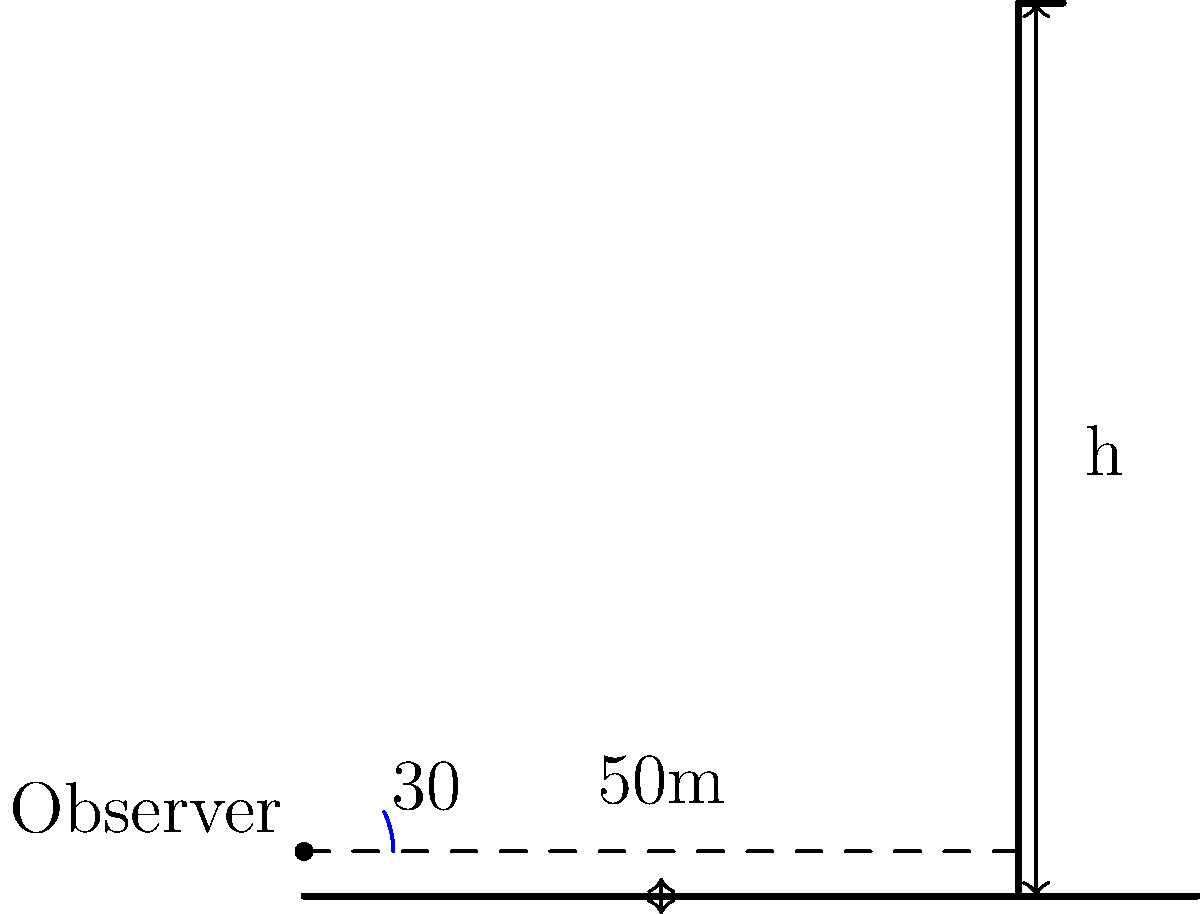As an Instagrammer looking to boost engagement, you're creating a post about a tall building in your city. You're standing 50 meters away from the base of the building and observe its top at an angle of 30° above the horizontal. Using the tangent function, calculate the height of the building. Round your answer to the nearest meter. Let's approach this step-by-step:

1) In this problem, we're dealing with a right-angled triangle. The building's height is the opposite side, and the distance from the observer to the building is the adjacent side.

2) We know that:
   - The angle of elevation is 30°
   - The adjacent side (distance to the building) is 50 meters

3) We need to find the opposite side (height of the building). Let's call this height $h$.

4) The tangent function is defined as the ratio of the opposite side to the adjacent side:

   $\tan \theta = \frac{\text{opposite}}{\text{adjacent}}$

5) Plugging in our known values:

   $\tan 30° = \frac{h}{50}$

6) We can rearrange this to solve for $h$:

   $h = 50 \tan 30°$

7) Now, let's calculate:
   - $\tan 30° \approx 0.5773$
   - $h = 50 \times 0.5773 = 28.8650$ meters

8) Rounding to the nearest meter:

   $h \approx 29$ meters

Therefore, the height of the building is approximately 29 meters.
Answer: 29 meters 